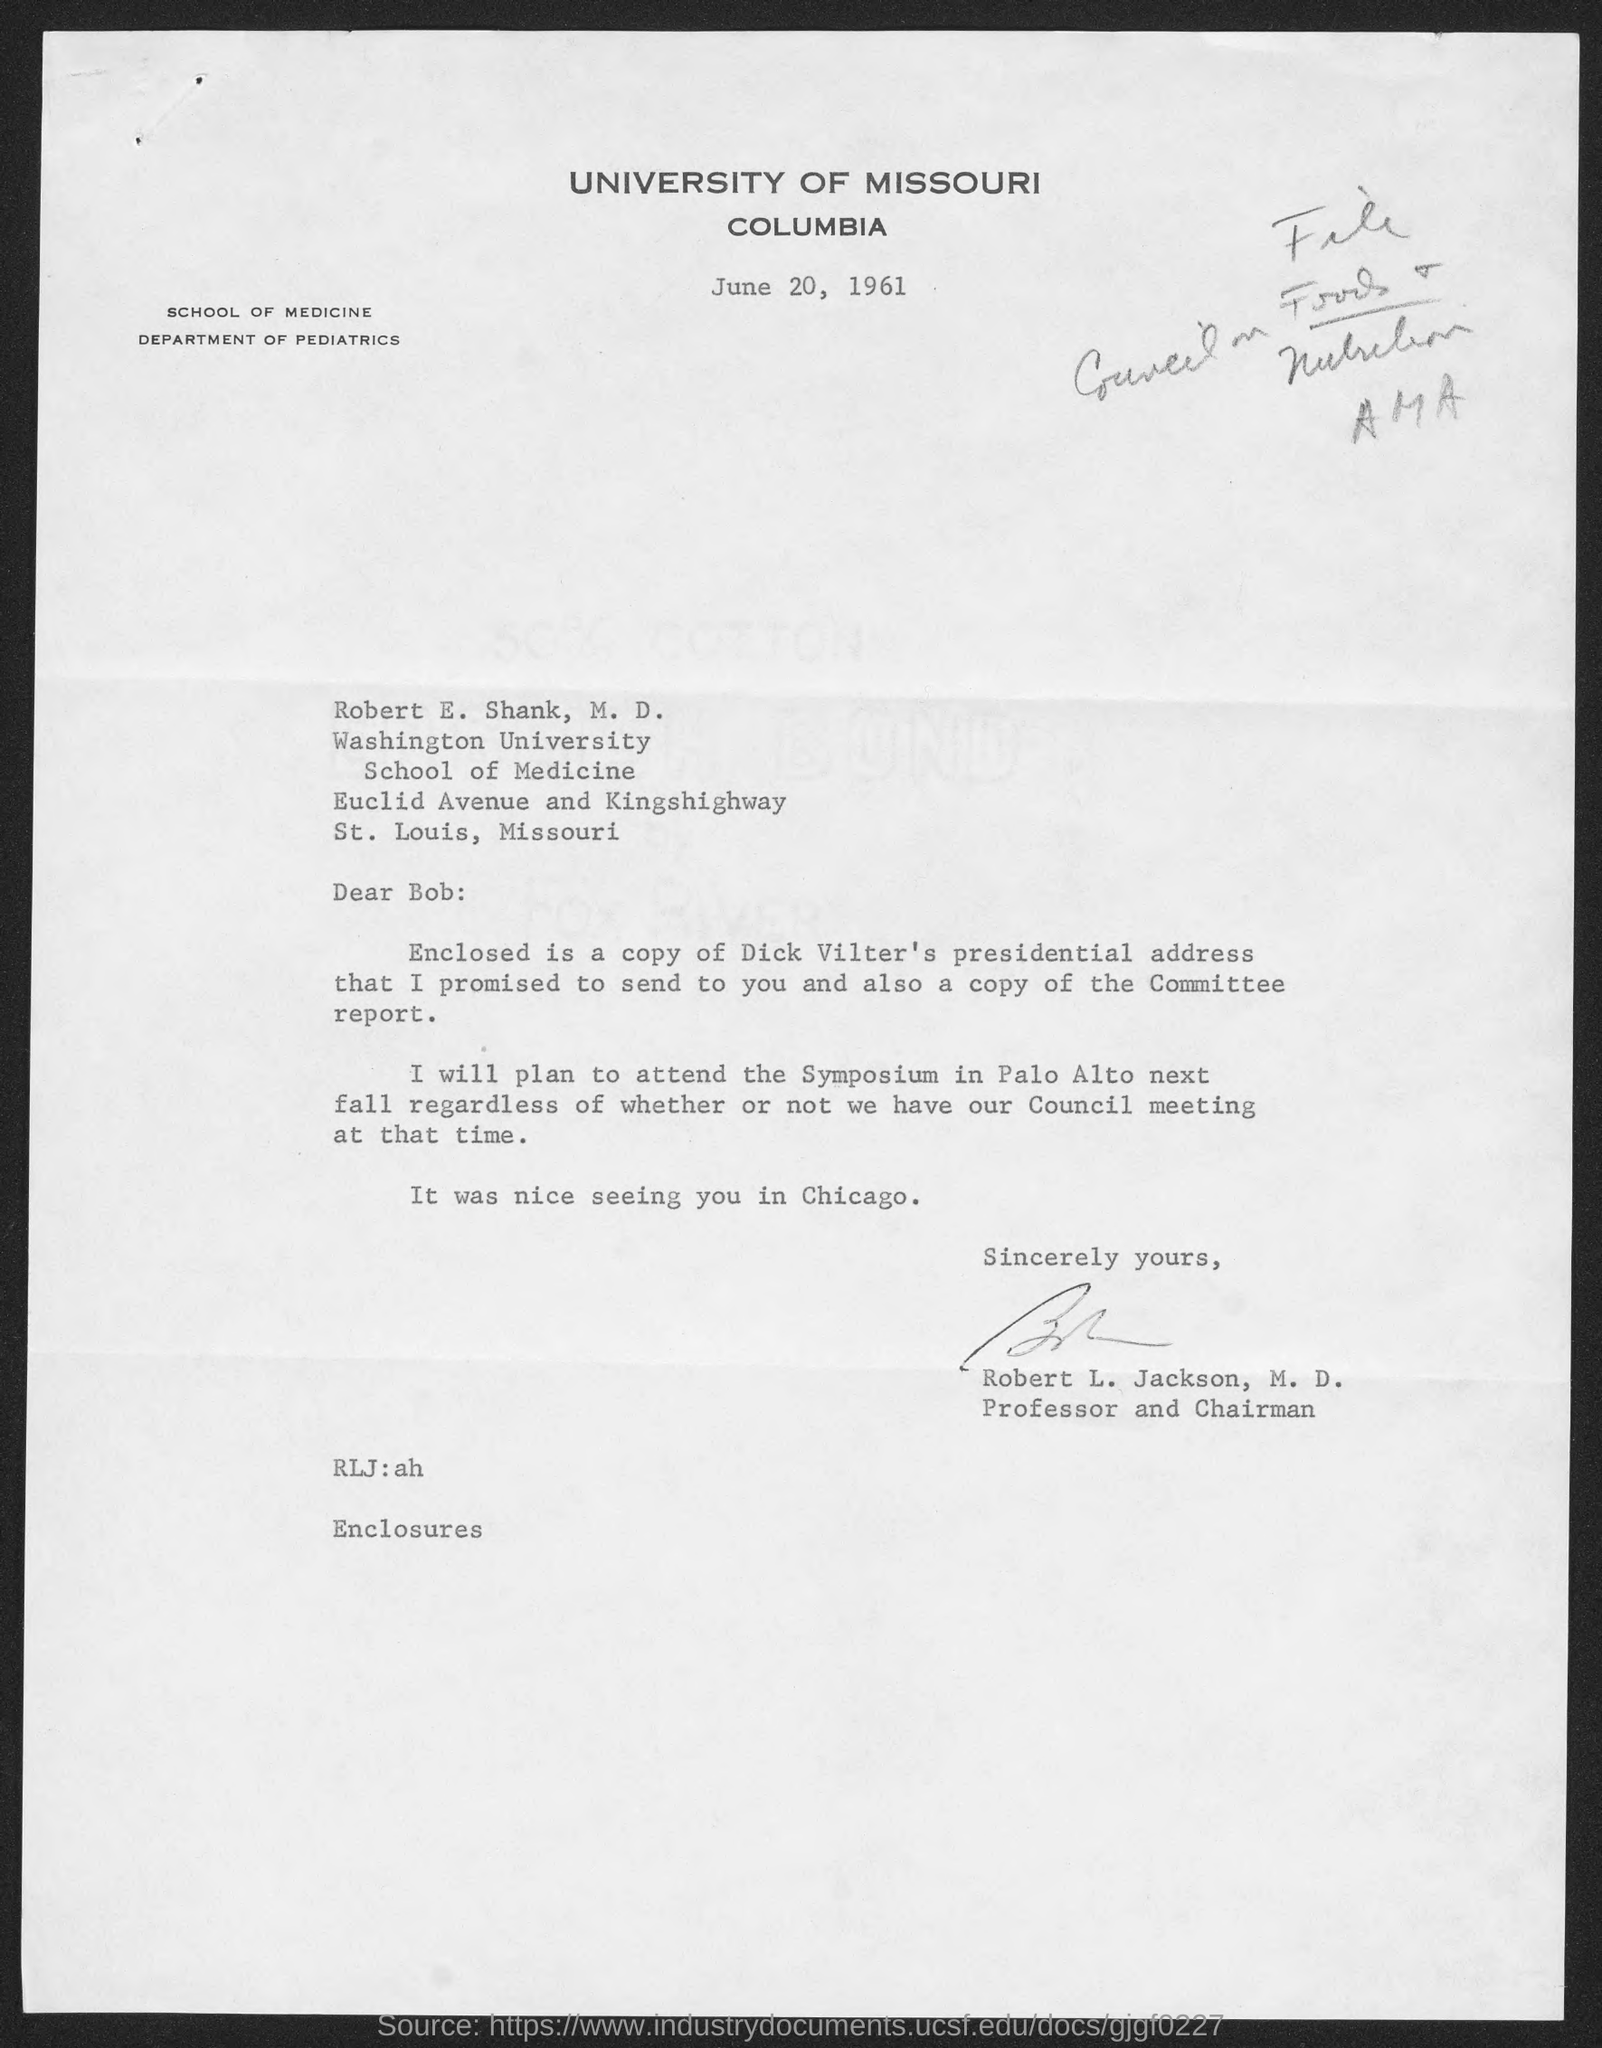Where is university of missouri located at?
Keep it short and to the point. Columbia. 